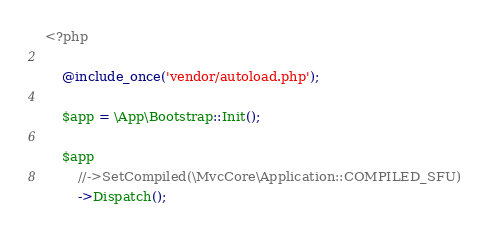Convert code to text. <code><loc_0><loc_0><loc_500><loc_500><_PHP_><?php

	@include_once('vendor/autoload.php');

	$app = \App\Bootstrap::Init();

	$app
		//->SetCompiled(\MvcCore\Application::COMPILED_SFU)
		->Dispatch();
</code> 